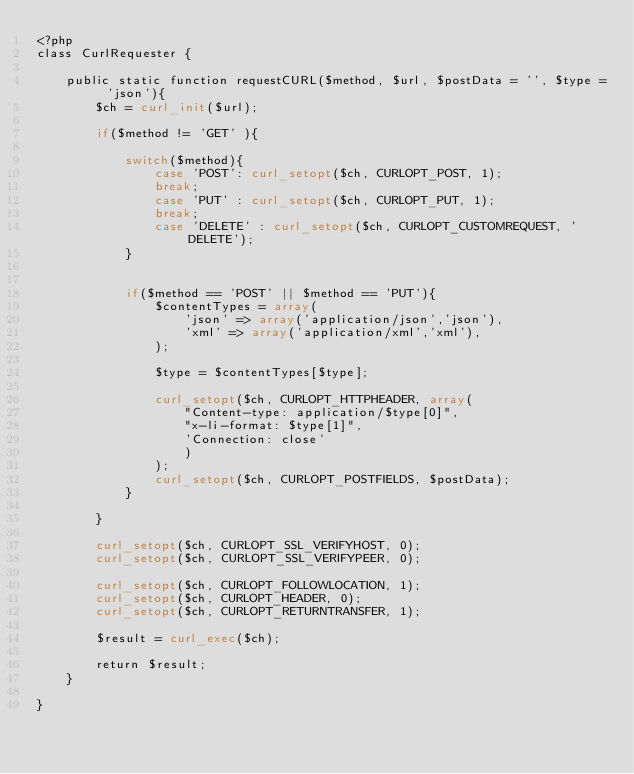Convert code to text. <code><loc_0><loc_0><loc_500><loc_500><_PHP_><?php
class CurlRequester {

    public static function requestCURL($method, $url, $postData = '', $type = 'json'){
        $ch = curl_init($url);

        if($method != 'GET' ){

            switch($method){
                case 'POST': curl_setopt($ch, CURLOPT_POST, 1);
                break;
                case 'PUT' : curl_setopt($ch, CURLOPT_PUT, 1);
                break;
                case 'DELETE' : curl_setopt($ch, CURLOPT_CUSTOMREQUEST, 'DELETE');
            }


            if($method == 'POST' || $method == 'PUT'){
                $contentTypes = array(
                    'json' => array('application/json','json'),
                    'xml' => array('application/xml','xml'),
                );

                $type = $contentTypes[$type];

                curl_setopt($ch, CURLOPT_HTTPHEADER, array(
                    "Content-type: application/$type[0]",
                    "x-li-format: $type[1]",
                    'Connection: close'
                    )
                );
                curl_setopt($ch, CURLOPT_POSTFIELDS, $postData);
            }

        }

        curl_setopt($ch, CURLOPT_SSL_VERIFYHOST, 0);
        curl_setopt($ch, CURLOPT_SSL_VERIFYPEER, 0);

        curl_setopt($ch, CURLOPT_FOLLOWLOCATION, 1);
        curl_setopt($ch, CURLOPT_HEADER, 0);
        curl_setopt($ch, CURLOPT_RETURNTRANSFER, 1);

        $result = curl_exec($ch);

        return $result;
    }

}</code> 